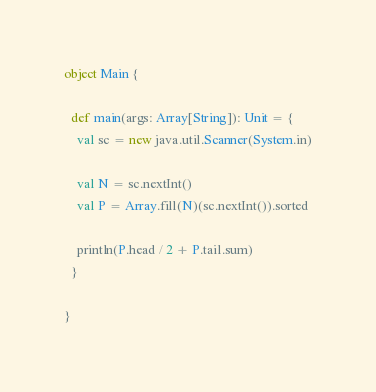<code> <loc_0><loc_0><loc_500><loc_500><_Scala_>object Main {

  def main(args: Array[String]): Unit = {
    val sc = new java.util.Scanner(System.in)

    val N = sc.nextInt()
    val P = Array.fill(N)(sc.nextInt()).sorted

    println(P.head / 2 + P.tail.sum)
  }

}</code> 